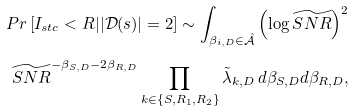Convert formula to latex. <formula><loc_0><loc_0><loc_500><loc_500>P r \left [ I _ { s t c } < R | | { \mathcal { D } } ( s ) | = 2 \right ] \sim \int _ { \beta _ { i , D } \in \hat { \mathcal { A } } } \left ( \log \widetilde { S N R } \right ) ^ { 2 } \\ \widetilde { S N R } ^ { - \beta _ { S , D } - 2 \beta _ { R , D } } \prod _ { k \in \left \{ S , R _ { 1 } , R _ { 2 } \right \} } \tilde { \lambda } _ { k , D } \, d \beta _ { S , D } d \beta _ { R , D } ,</formula> 